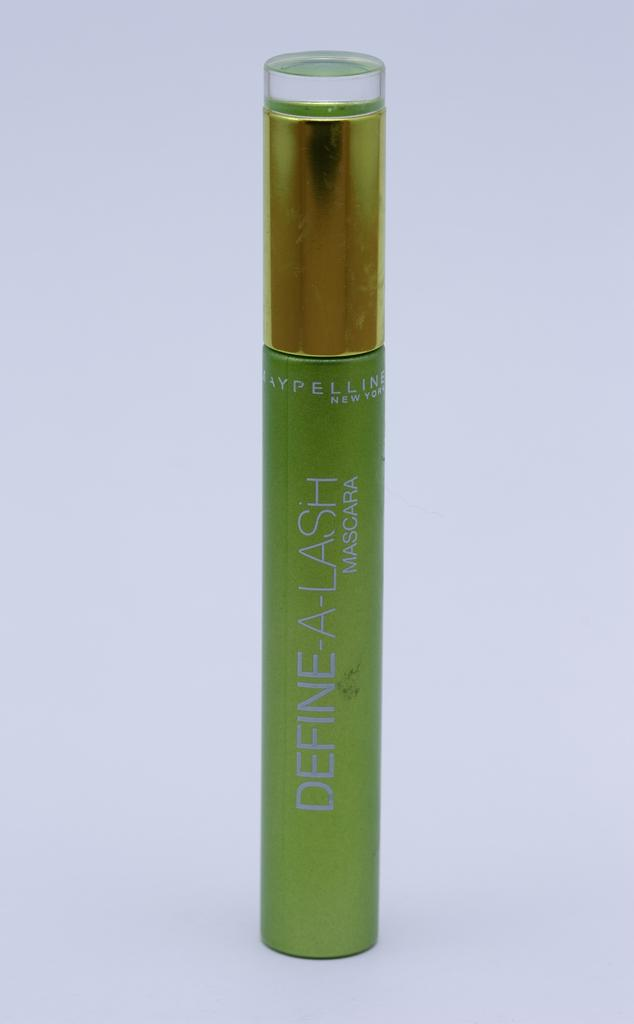Provide a one-sentence caption for the provided image. green tube of define-a-lash mascara by maybelline new york. 